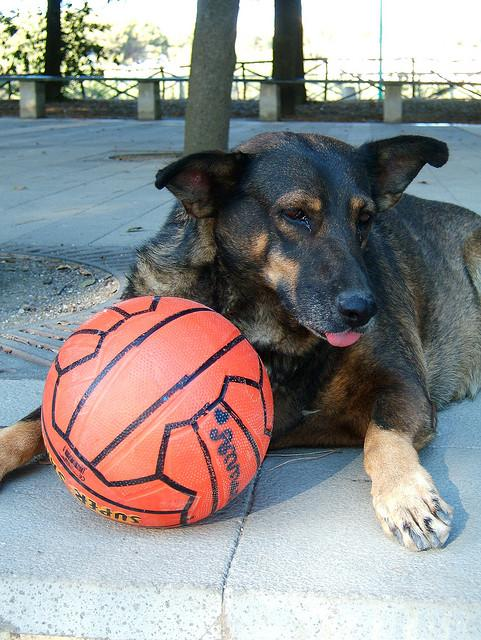What kind of ball is the dog sitting next to on the concrete? basketball 